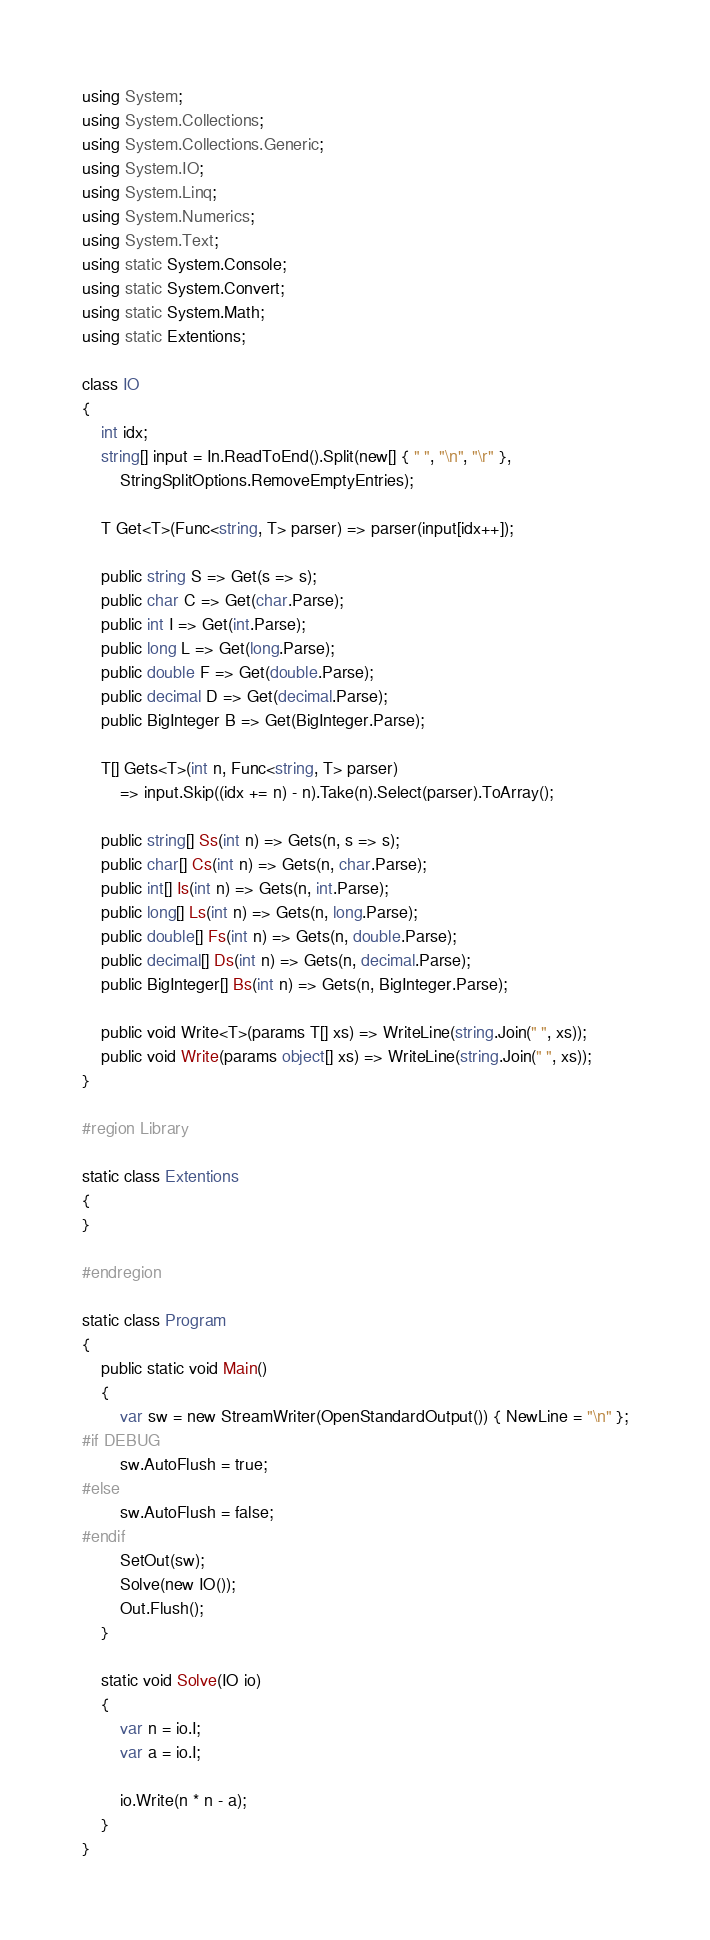<code> <loc_0><loc_0><loc_500><loc_500><_C#_>using System;
using System.Collections;
using System.Collections.Generic;
using System.IO;
using System.Linq;
using System.Numerics;
using System.Text;
using static System.Console;
using static System.Convert;
using static System.Math;
using static Extentions;

class IO
{
    int idx;
    string[] input = In.ReadToEnd().Split(new[] { " ", "\n", "\r" },
        StringSplitOptions.RemoveEmptyEntries);

    T Get<T>(Func<string, T> parser) => parser(input[idx++]);

    public string S => Get(s => s);
    public char C => Get(char.Parse);
    public int I => Get(int.Parse);
    public long L => Get(long.Parse);
    public double F => Get(double.Parse);
    public decimal D => Get(decimal.Parse);
    public BigInteger B => Get(BigInteger.Parse);

    T[] Gets<T>(int n, Func<string, T> parser)
        => input.Skip((idx += n) - n).Take(n).Select(parser).ToArray();

    public string[] Ss(int n) => Gets(n, s => s);
    public char[] Cs(int n) => Gets(n, char.Parse);
    public int[] Is(int n) => Gets(n, int.Parse);
    public long[] Ls(int n) => Gets(n, long.Parse);
    public double[] Fs(int n) => Gets(n, double.Parse);
    public decimal[] Ds(int n) => Gets(n, decimal.Parse);
    public BigInteger[] Bs(int n) => Gets(n, BigInteger.Parse);

    public void Write<T>(params T[] xs) => WriteLine(string.Join(" ", xs));
    public void Write(params object[] xs) => WriteLine(string.Join(" ", xs));
}

#region Library

static class Extentions
{
}

#endregion

static class Program
{
    public static void Main()
    {
        var sw = new StreamWriter(OpenStandardOutput()) { NewLine = "\n" };
#if DEBUG
        sw.AutoFlush = true;
#else
        sw.AutoFlush = false;
#endif
        SetOut(sw);
        Solve(new IO());
        Out.Flush();
    }

    static void Solve(IO io)
    {
        var n = io.I;
        var a = io.I;

        io.Write(n * n - a);
    }
}</code> 